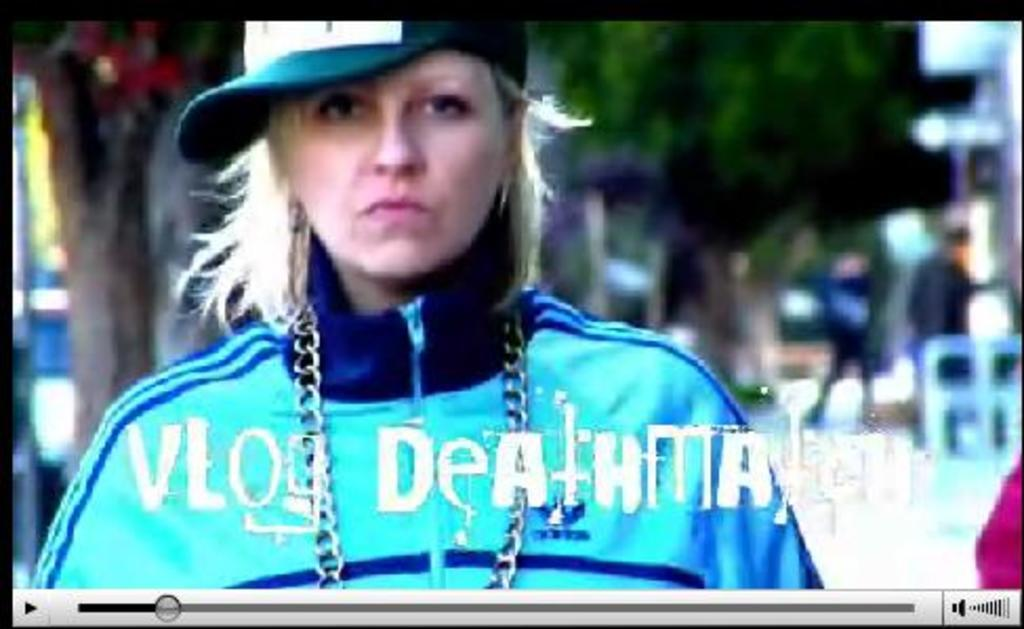What is the main object in the image? There is a screen in the image. What can be seen on the screen? A woman wearing a cap is visible on the screen. How is the background depicted on the screen? The background in the screen is blurry. What type of plastic material is being used by the mother in the image? There is no mother or plastic material present in the image; it only features a screen with a woman wearing a cap. 